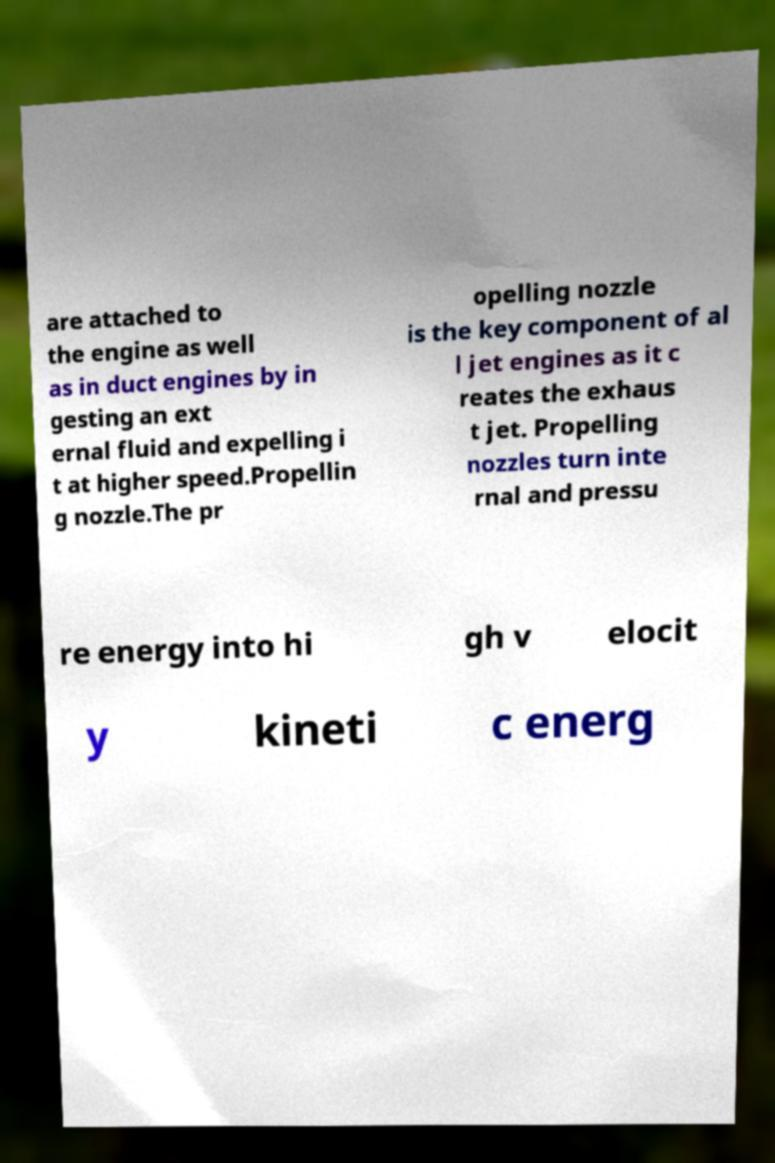For documentation purposes, I need the text within this image transcribed. Could you provide that? are attached to the engine as well as in duct engines by in gesting an ext ernal fluid and expelling i t at higher speed.Propellin g nozzle.The pr opelling nozzle is the key component of al l jet engines as it c reates the exhaus t jet. Propelling nozzles turn inte rnal and pressu re energy into hi gh v elocit y kineti c energ 